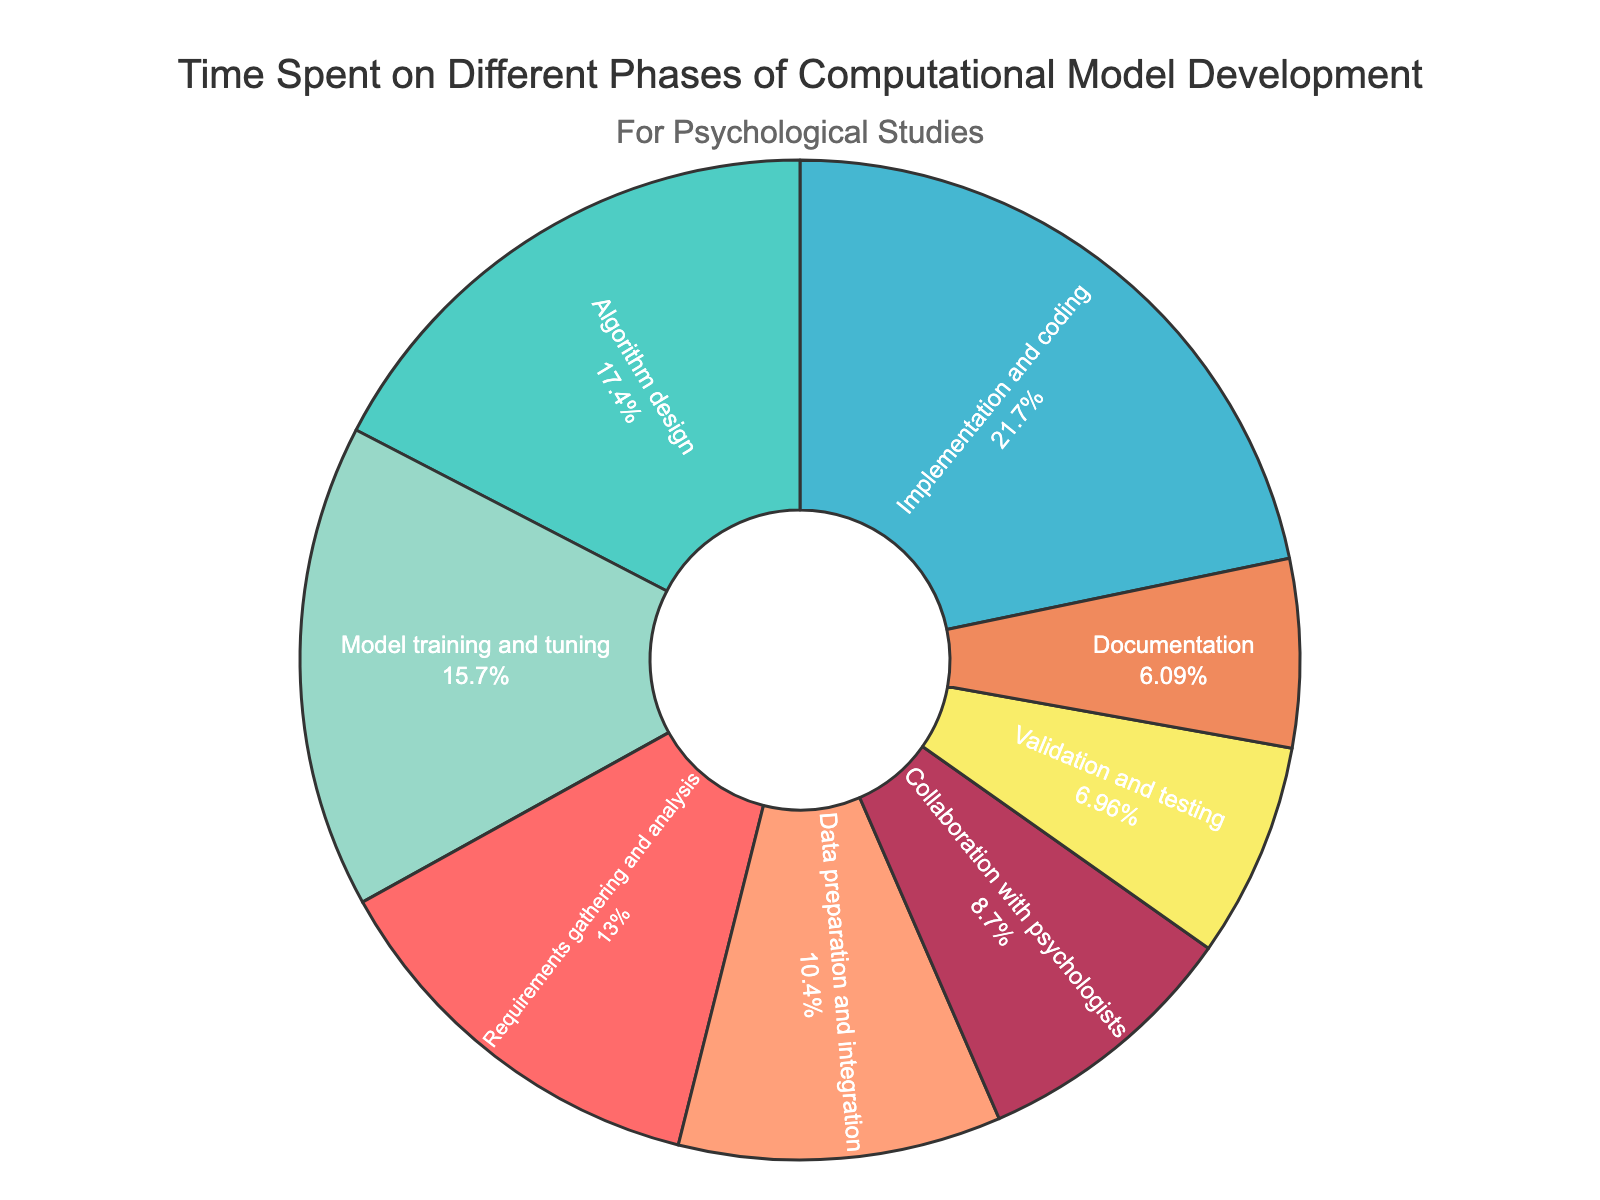What's the largest segment in the pie chart? The largest segment in the pie chart can be identified by looking at the percentage values. The segment with the highest percentage is "Implementation and coding" with 25%.
Answer: Implementation and coding What's the smallest segment in the pie chart? The smallest segment can be identified by locating the segment with the lowest percentage value. The "Documentation" segment is the smallest with 7%.
Answer: Documentation What percentage of total time is spent on Algorithm design and Data preparation and integration combined? First, identify the percentages for Algorithm design (20%) and Data preparation and integration (12%). Then, sum them up: 20% + 12% = 32%.
Answer: 32% Which phase spent more time, Model training and tuning or Collaboration with psychologists? Compare the percentages of the phases: Model training and tuning is 18%, and Collaboration with psychologists is 10%. Since 18% > 10%, more time is spent on Model training and tuning.
Answer: Model training and tuning What is the difference in time spent between Requirements gathering and analysis and Validation and testing? Identify the percentages for Requirements gathering and analysis (15%) and Validation and testing (8%). Subtract the smaller percentage from the larger one: 15% - 8% = 7%.
Answer: 7% Are there any phases that have the same percentage of time spent? By examining the percentages in the pie chart, we can see that no two phases have the same percentage. Each segment has a unique percentage value.
Answer: No What color is the segment representing Data preparation and integration? By examining the pie chart, the Data preparation and integration segment is represented by the green color (fourth color in the legend).
Answer: Green Which segment has the second-largest percentage of total time spent? Identify the largest percentage first, which is Implementation and coding (25%). The next largest is Algorithm design with 20%. Therefore, Algorithm design has the second-largest percentage.
Answer: Algorithm design What is the total percentage of time spent on Validation and testing and Documentation combined? Identify the percentages for both Validation and testing (8%) and Documentation (7%). Then, sum them up: 8% + 7% = 15%.
Answer: 15% How does the time spent on Collaboration with psychologists compare to Requirements gathering and analysis? Compare the percentages of Collaboration with psychologists (10%) and Requirements gathering and analysis (15%). Collaboration with psychologists has a smaller percentage.
Answer: Less 